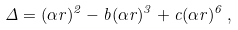<formula> <loc_0><loc_0><loc_500><loc_500>\Delta = ( \alpha r ) ^ { 2 } - b ( \alpha r ) ^ { 3 } + c ( \alpha r ) ^ { 6 } \, , \\</formula> 